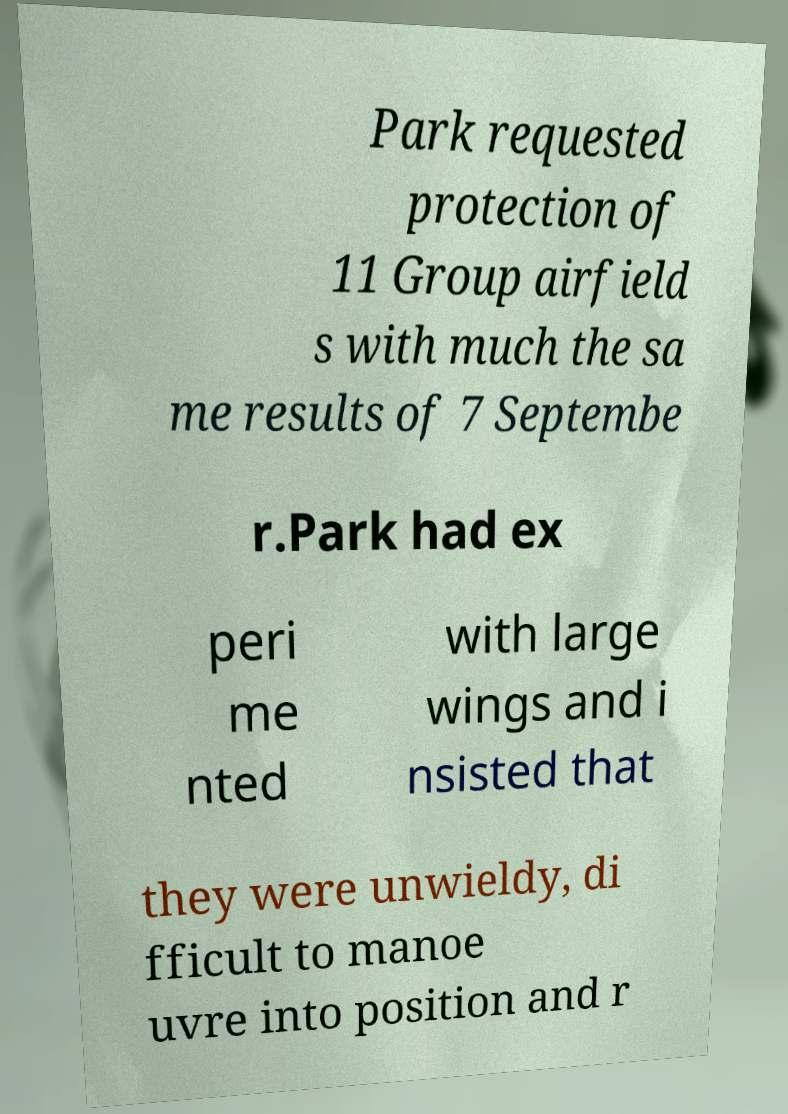Could you assist in decoding the text presented in this image and type it out clearly? Park requested protection of 11 Group airfield s with much the sa me results of 7 Septembe r.Park had ex peri me nted with large wings and i nsisted that they were unwieldy, di fficult to manoe uvre into position and r 